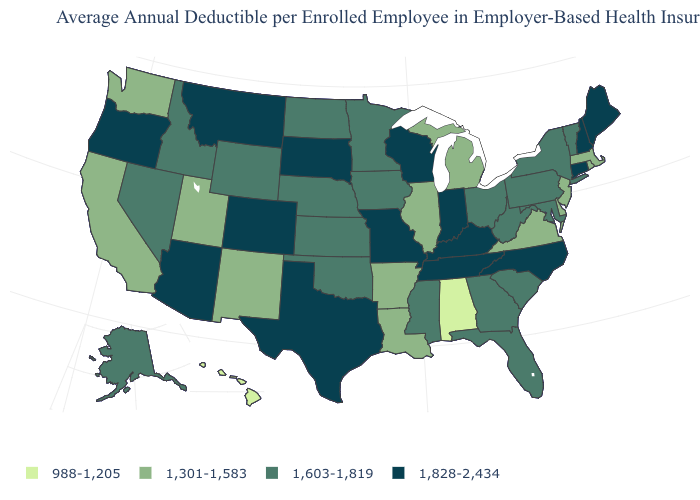Does Arizona have the highest value in the USA?
Be succinct. Yes. Does South Dakota have a lower value than California?
Short answer required. No. What is the value of Texas?
Answer briefly. 1,828-2,434. Name the states that have a value in the range 1,603-1,819?
Write a very short answer. Alaska, Florida, Georgia, Idaho, Iowa, Kansas, Maryland, Minnesota, Mississippi, Nebraska, Nevada, New York, North Dakota, Ohio, Oklahoma, Pennsylvania, South Carolina, Vermont, West Virginia, Wyoming. Name the states that have a value in the range 1,828-2,434?
Short answer required. Arizona, Colorado, Connecticut, Indiana, Kentucky, Maine, Missouri, Montana, New Hampshire, North Carolina, Oregon, South Dakota, Tennessee, Texas, Wisconsin. What is the value of Oklahoma?
Write a very short answer. 1,603-1,819. What is the value of Massachusetts?
Answer briefly. 1,301-1,583. Does Texas have the highest value in the USA?
Write a very short answer. Yes. What is the highest value in the West ?
Be succinct. 1,828-2,434. Does the map have missing data?
Quick response, please. No. What is the lowest value in the South?
Be succinct. 988-1,205. What is the value of Virginia?
Answer briefly. 1,301-1,583. Name the states that have a value in the range 1,828-2,434?
Write a very short answer. Arizona, Colorado, Connecticut, Indiana, Kentucky, Maine, Missouri, Montana, New Hampshire, North Carolina, Oregon, South Dakota, Tennessee, Texas, Wisconsin. Which states have the lowest value in the USA?
Write a very short answer. Alabama, Hawaii. Name the states that have a value in the range 1,301-1,583?
Give a very brief answer. Arkansas, California, Delaware, Illinois, Louisiana, Massachusetts, Michigan, New Jersey, New Mexico, Rhode Island, Utah, Virginia, Washington. 